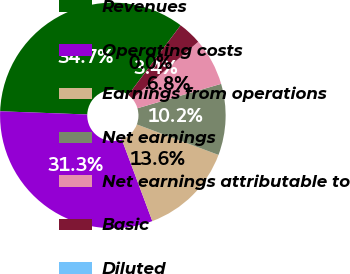<chart> <loc_0><loc_0><loc_500><loc_500><pie_chart><fcel>Revenues<fcel>Operating costs<fcel>Earnings from operations<fcel>Net earnings<fcel>Net earnings attributable to<fcel>Basic<fcel>Diluted<nl><fcel>34.68%<fcel>31.28%<fcel>13.62%<fcel>10.21%<fcel>6.81%<fcel>3.41%<fcel>0.0%<nl></chart> 